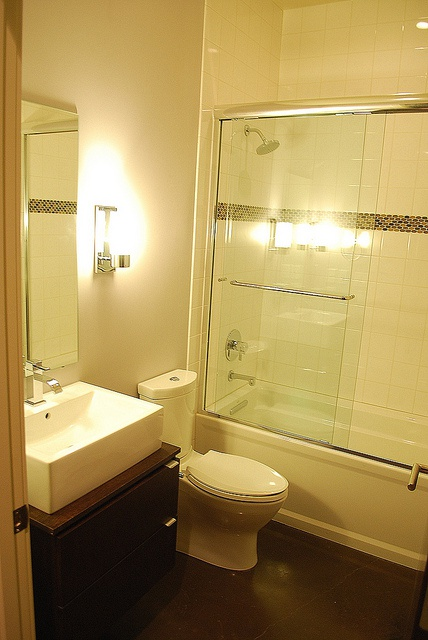Describe the objects in this image and their specific colors. I can see toilet in olive, maroon, khaki, and tan tones and sink in olive, lightyellow, khaki, and tan tones in this image. 